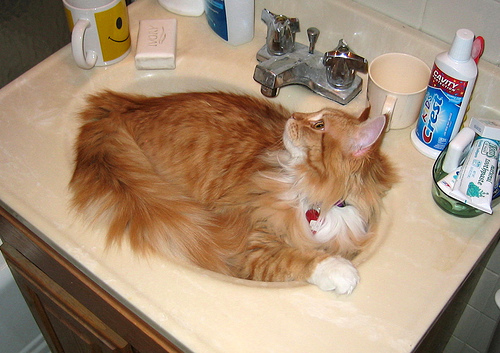Please transcribe the text information in this image. Crest CAVITY 